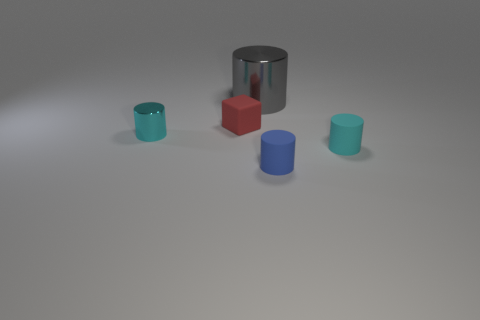Do the small cylinder on the left side of the large gray thing and the tiny thing that is to the right of the blue rubber cylinder have the same color?
Offer a very short reply. Yes. Are there any other things that have the same color as the tiny shiny cylinder?
Provide a succinct answer. Yes. What material is the blue thing that is the same shape as the gray metallic object?
Ensure brevity in your answer.  Rubber. There is a tiny cylinder to the right of the blue rubber cylinder; does it have the same color as the small shiny object?
Offer a very short reply. Yes. There is a blue rubber thing; does it have the same size as the metal cylinder behind the small cyan shiny cylinder?
Provide a succinct answer. No. Is there a metallic object of the same size as the blue matte cylinder?
Your answer should be very brief. Yes. How many other objects are there of the same material as the tiny block?
Your answer should be compact. 2. The tiny object that is both behind the blue matte object and right of the gray metallic cylinder is what color?
Offer a terse response. Cyan. Is the small cyan cylinder left of the tiny blue matte thing made of the same material as the cylinder behind the tiny red rubber thing?
Give a very brief answer. Yes. There is a thing on the left side of the red rubber object; is it the same size as the small red matte cube?
Your answer should be very brief. Yes. 